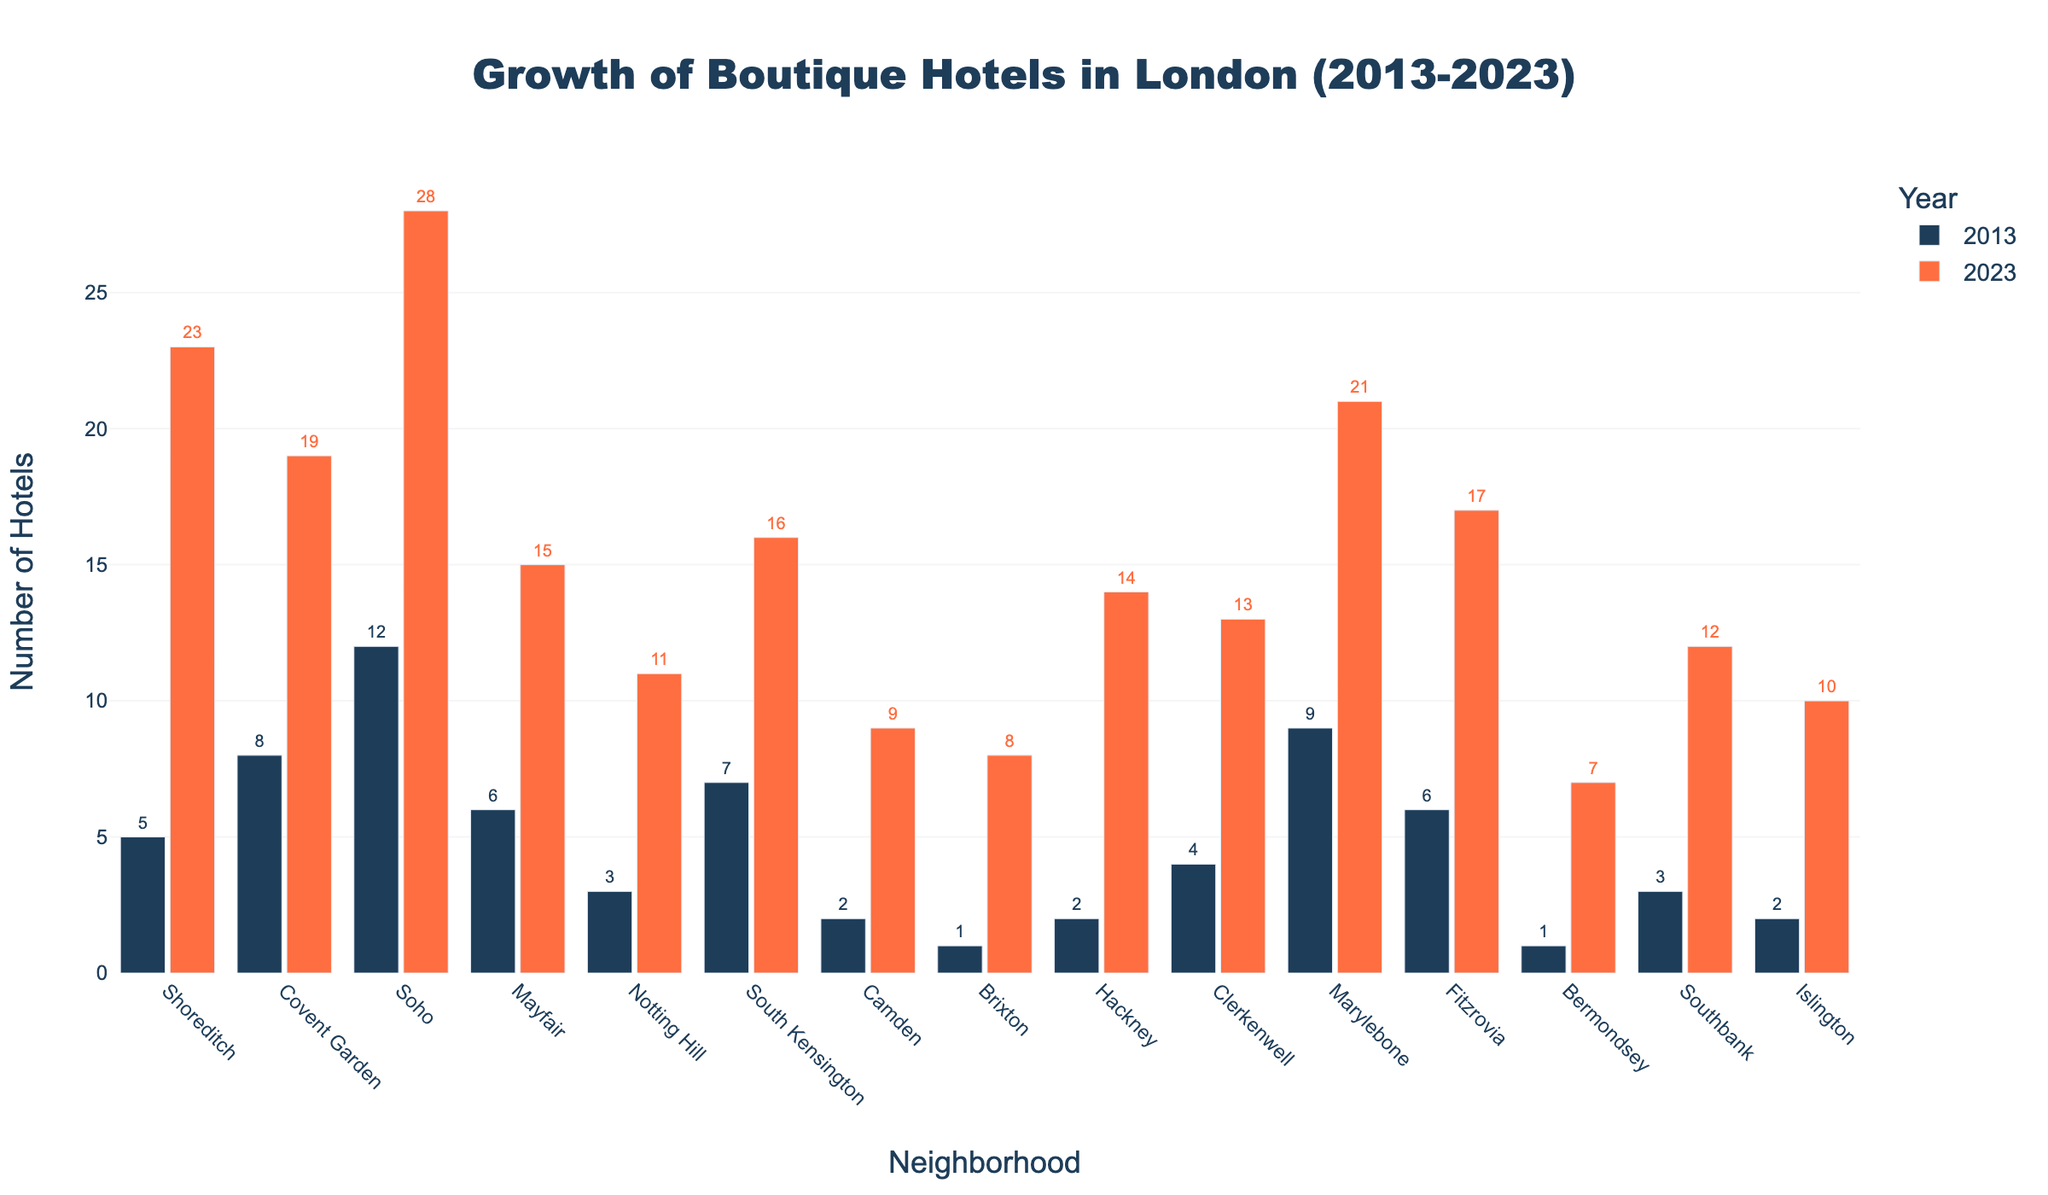Which neighborhood had the highest growth in boutique hotels from 2013 to 2023? Find the difference between the counts of boutique hotels in 2023 and 2013 for each neighborhood, then identify the maximum value. Soho had 28 in 2023 and 12 in 2013, giving an increase of 16, the highest.
Answer: Soho Which neighborhood had more boutique hotels in 2023, Notting Hill or Camden? Compare the hotel count in 2023: Notting Hill has 11 and Camden has 9.
Answer: Notting Hill What is the total number of boutique hotels in Shoreditch and Covent Garden in 2023? Add the 2023 counts for Shoreditch (23) and Covent Garden (19).
Answer: 42 How many more boutique hotels were there in Marylebone in 2023 compared to 2013? Subtract the 2013 count (9) from the 2023 count (21) for Marylebone.
Answer: 12 Which neighborhood had the smallest increase in boutique hotels from 2013 to 2023? Find the difference between the counts of boutique hotels in 2023 and 2013 for each neighborhood, then identify the minimum value. Bermondsey had an increase of 6 (from 1 to 7), the smallest.
Answer: Bermondsey Between Brixton and Hackney, which showed a greater percentage increase in the number of boutique hotels from 2013 to 2023? Calculate the percentage increase for both: Brixton increased from 1 to 8, which is a 700% increase (7/1 * 100), and Hackney increased from 2 to 14, which is a 600% increase (12/2 * 100).
Answer: Brixton How many neighborhoods had at least 10 boutique hotels in 2023? Count the neighborhoods where the 2023 value is 10 or more. There are ten neighborhoods: Shoreditch, Covent Garden, Soho, Mayfair, Notting Hill, South Kensington, Camden, Hackney, Clerkenwell, Marylebone, and Fitzrovia.
Answer: 10 Which year had the highest combined total number of boutique hotels across all neighborhoods: 2013 or 2023? Sum the counts for all neighborhoods in both years. The total for 2013 is 71, while the total for 2023 is 200.
Answer: 2023 What is the average number of boutique hotels across all neighborhoods in 2023? Sum the counts for 2023 across all neighborhoods and divide by the number of neighborhoods (15). The total is 200, so the average is 200/15.
Answer: 13.33 